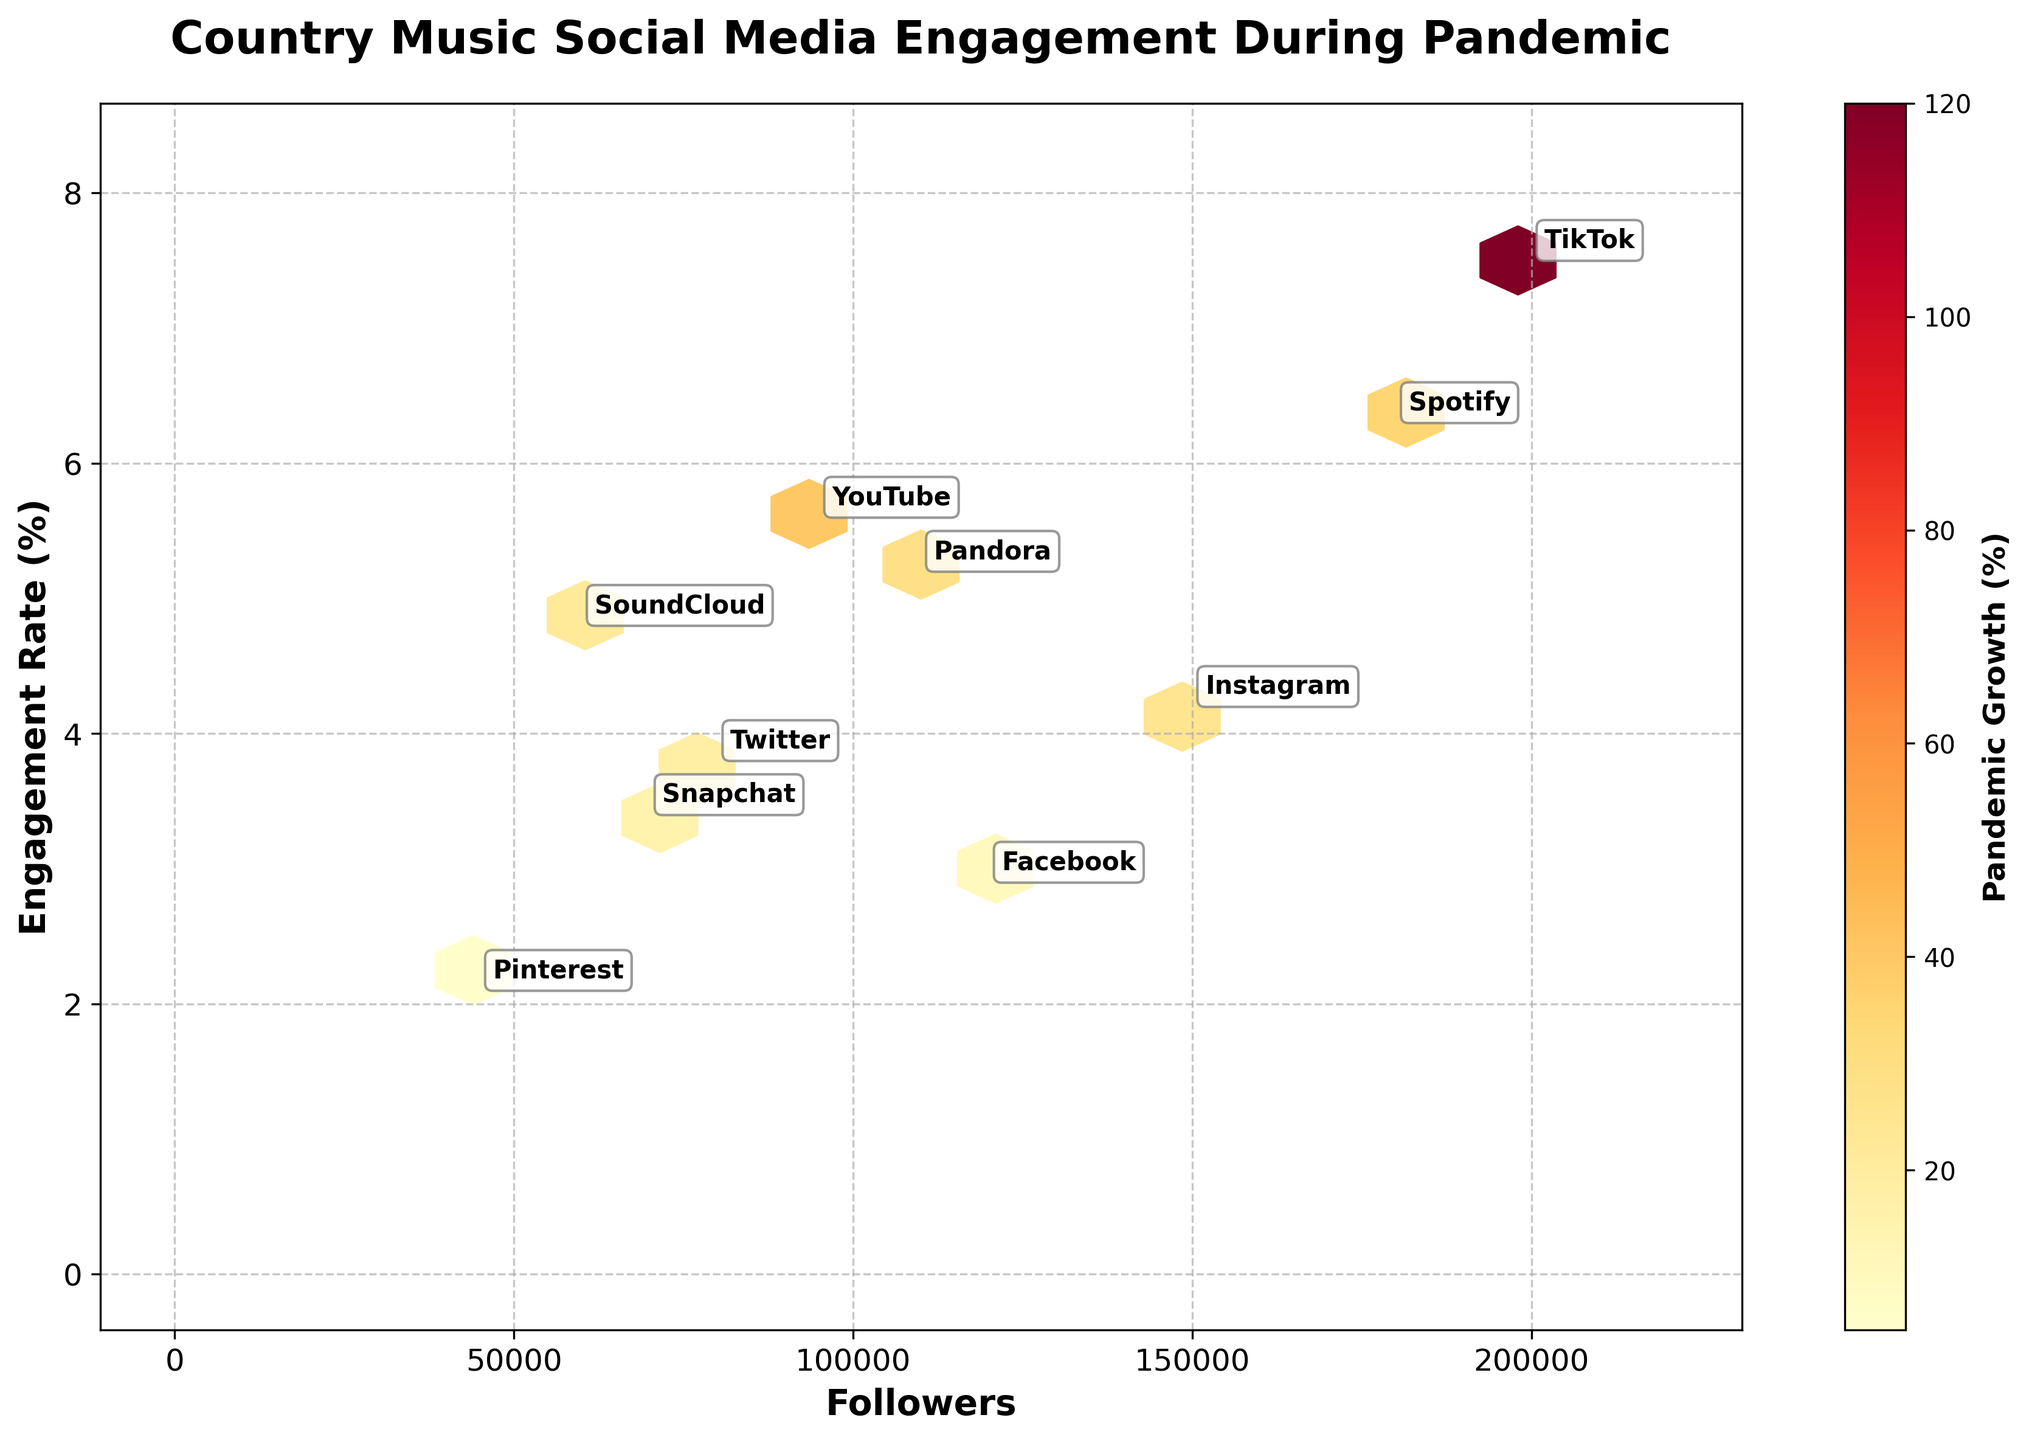what is the title of this figure? The title is displayed prominently at the top of the figure, which reads "Country Music Social Media Engagement During Pandemic".
Answer: Country Music Social Media Engagement During Pandemic Which platform has the highest engagement rate? By locating the highest y-value on the engagement rate axis (vertical axis) and finding the corresponding platform label, it is indicated that TikTok has the highest engagement rate.
Answer: TikTok Which platform has the highest number of followers? The platform with the highest number of followers is found by identifying the maximum x-value on the followers axis (horizontal axis) and finding the platform label associated with that value.
Answer: TikTok How many data points are represented in the figure? Each hexagon and platform label corresponds to a unique data point in the figure; counting them shows there are a total of 10 data points.
Answer: 10 What is the engagement rate of the platform with 180,000 followers? Locate the platform on the horizontal axis at 180,000 followers, and find the corresponding value on the vertical engagement rate axis. The platform label shows that Spotify's engagement rate is 6.3%.
Answer: 6.3% Which platform experienced the highest pandemic growth percentage? By examining the color intensity in the color bar and finding the platform associated with the most intense color, it indicated TikTok with 120% in the legend.
Answer: TikTok Which platforms have an engagement rate greater than 5%? Identify the platforms by their positions on the vertical axis being greater than 5.0%, which include YouTube, Spotify, TikTok, and Pandora.
Answer: YouTube, Spotify, TikTok, Pandora Which platform has more followers, YouTube or Pandora? Compare their values on the horizontal followers axis. YouTube, with 95,000 followers, has fewer followers compared to Pandora's 110,000 followers.
Answer: Pandora What is the average engagement rate of TikTok and YouTube? Add the engagement rates of TikTok (7.5%) and YouTube (5.6%), then divide by 2 to find the average. (7.5 + 5.6) / 2 = 6.55%
Answer: 6.55% Compare the pandemic growth percentage of Instagram and Facebook. Which is higher? By checking the color intensity corresponding to Instagram (25%) and Facebook (10%), Instagram has a higher pandemic growth percentage.
Answer: Instagram 